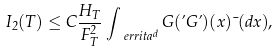<formula> <loc_0><loc_0><loc_500><loc_500>I _ { 2 } ( T ) \leq C \frac { H _ { T } } { F ^ { 2 } _ { T } } \int _ { \ e r r i t a ^ { d } } G ( \varphi G \varphi ) ( x ) \mu ( d x ) ,</formula> 